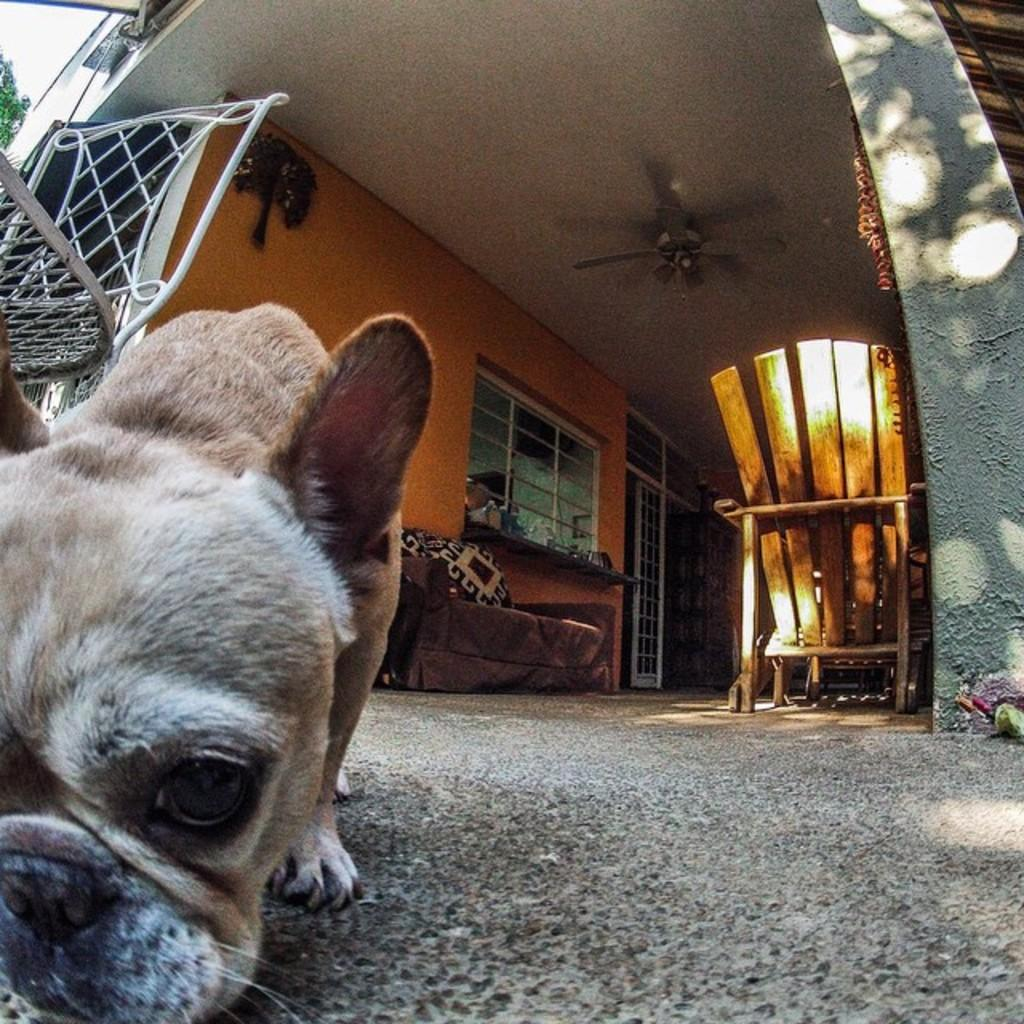What type of animal is present in the image? There is a dog in the image. What type of furniture can be seen in the image? There are chairs and a sofa in the image. What type of building is visible in the image? There is a house in the image. What type of lock is used to secure the dog in the image? There is no lock present in the image, and the dog is not secured. 